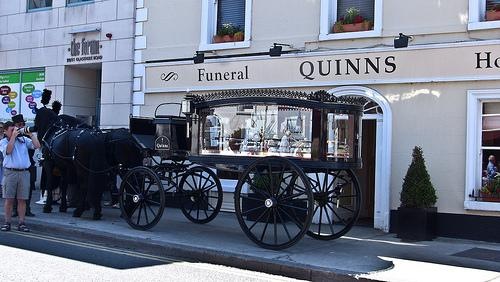Mention any animals present in the image and their characteristics. There are two black horses in the image, both attached to a black and white carriage. Their coats are black in color and they offer a side view of their bodies. What are the horses doing in the image, and what are they attached to? The horses are attached to a black and white carriage, pulling it on the road, offering a side view of their bodies. Is there a tree in the image? If so, describe it. Yes, there is a-small tree in a black pot by the building. What letters are mentioned in the image and their color? The letters mentioned are black and appear on the building. What are some visible features on the building in the image? Some visible features on the building include a door, a window, black letters, and words on it. Is the photo taken indoors or outdoors, and during which time of day? The photo is taken outdoors during the daytime. Based on the information provided, describe the scene captured in the image. The image features a black and white horse-drawn carriage in front of a funeral home, with two black horses attached to it. A man is taking a picture with a camera, and another man stands behind him. They are both wearing sunglasses, white shirts, and tan pants. The photo is taken outdoors during the daytime. What is the main color of the horse-drawn carriage and its wheels? The main color of the horse-drawn carriage is black and white, and its wheels are black. Choose one of the tasks mentioned above, and create an advertisement based on the information provided. "Experience a traditional ride with our elegant black and white horse-drawn carriages, pulled by majestic black horses. Perfect for weddings, funerals, and special occasions. Book now and capture unforgettable memories with our charming carriage on wheels!" Describe the appearance of the two people in the foreground of the photo. The two people in the foreground are both men wearing white shirts, tan pants or shorts, and sunglasses. One is holding a camera and taking a picture, while the other stands behind him. 